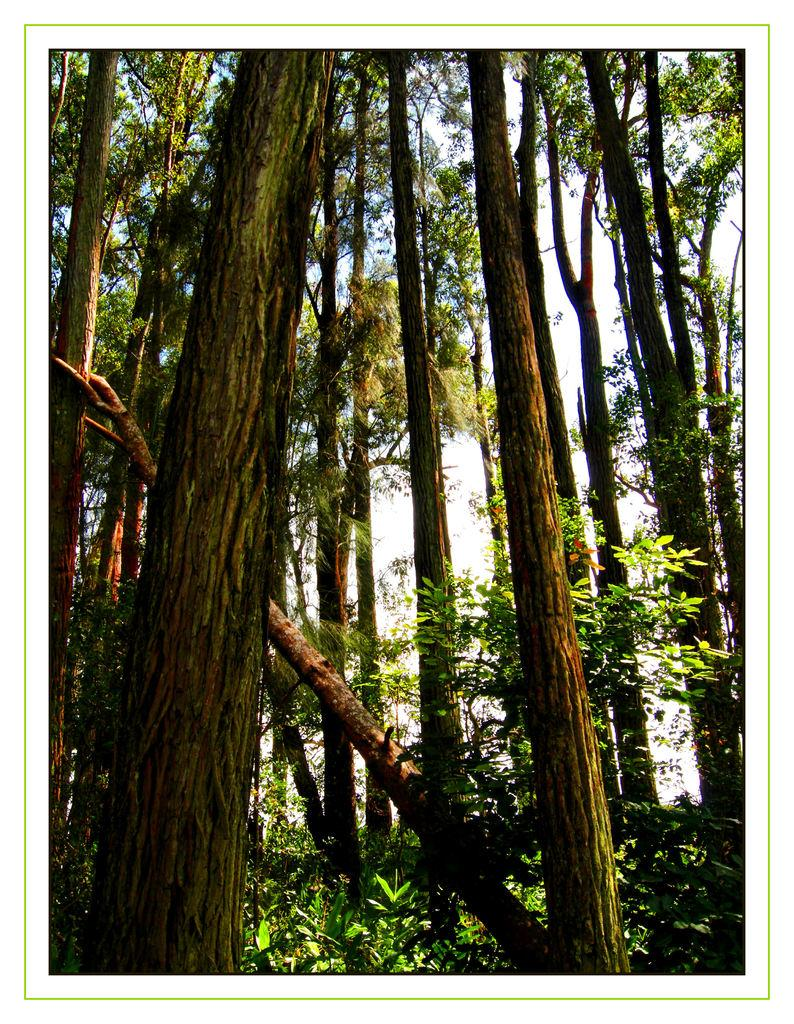What type of vegetation can be seen in the image? There is a group of trees and plants in the image. What can be seen in the background of the image? The sky is visible in the background of the image. Where is the order placed for the cars in the image? There are no cars or orders present in the image; it features a group of trees and plants with the sky visible in the background. 